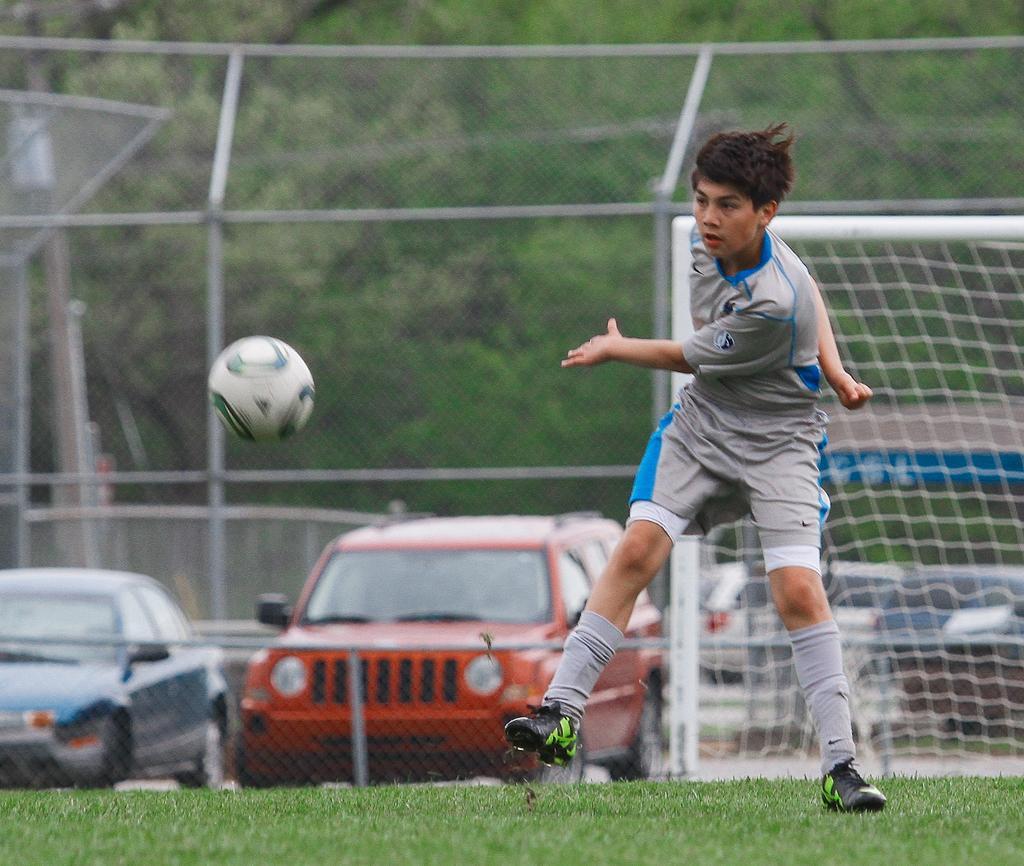Can you describe this image briefly? In the foreground of the picture we can see a person, ball and grass. In the middle there are vehicles, goal post and fencing. In the background there is greenery. 